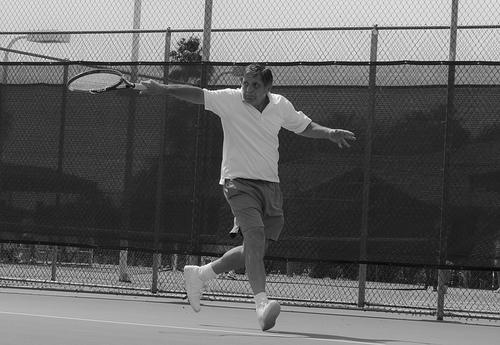Question: what game is the man playing?
Choices:
A. Basketball.
B. Tennis.
C. Football.
D. Soccer.
Answer with the letter. Answer: B Question: how many lamp post are there?
Choices:
A. 9.
B. 1.
C. 8.
D. 4.
Answer with the letter. Answer: B 